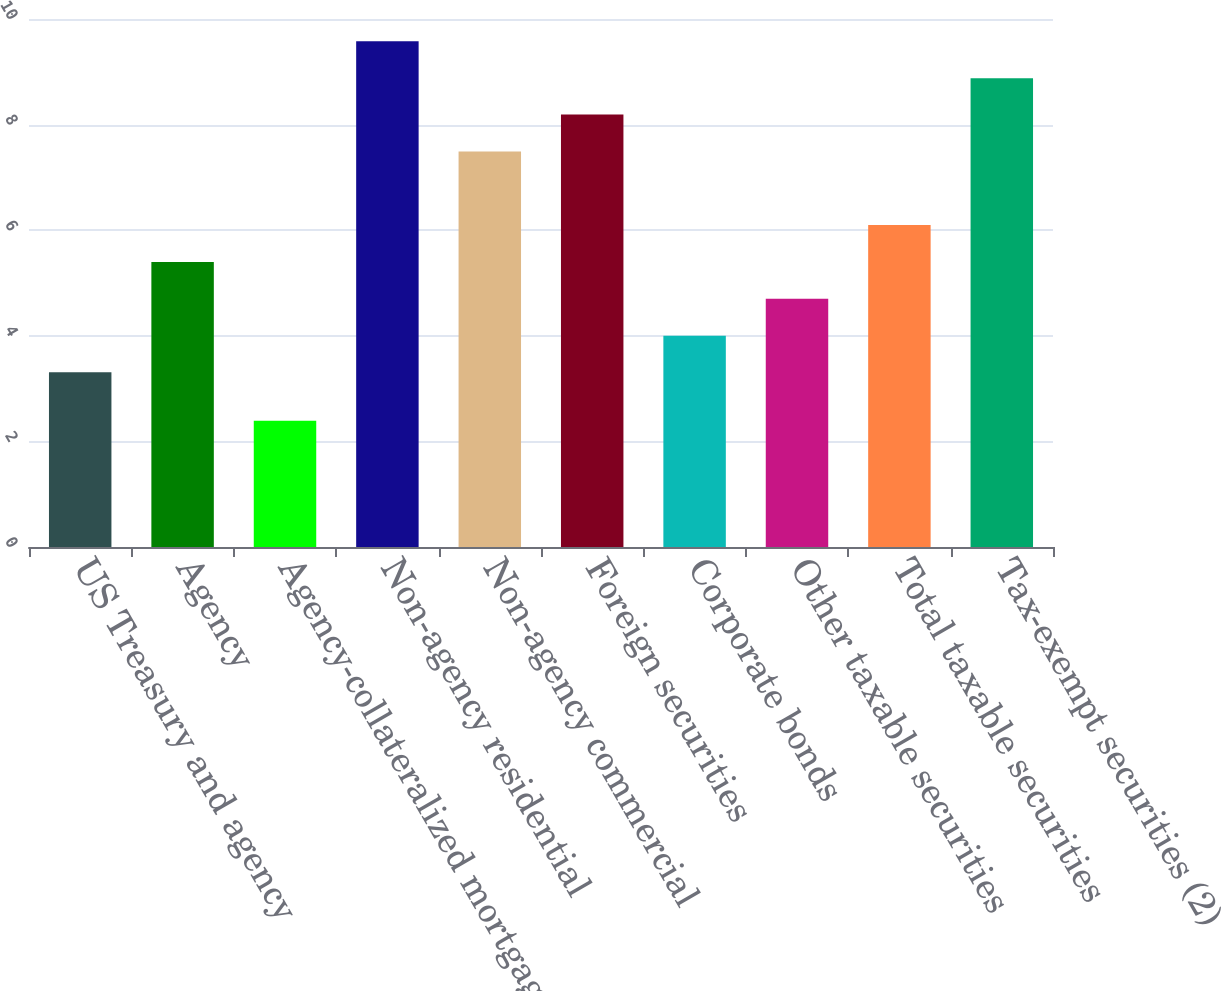Convert chart to OTSL. <chart><loc_0><loc_0><loc_500><loc_500><bar_chart><fcel>US Treasury and agency<fcel>Agency<fcel>Agency-collateralized mortgage<fcel>Non-agency residential<fcel>Non-agency commercial<fcel>Foreign securities<fcel>Corporate bonds<fcel>Other taxable securities<fcel>Total taxable securities<fcel>Tax-exempt securities (2)<nl><fcel>3.31<fcel>5.4<fcel>2.39<fcel>9.58<fcel>7.49<fcel>8.19<fcel>4<fcel>4.7<fcel>6.1<fcel>8.88<nl></chart> 